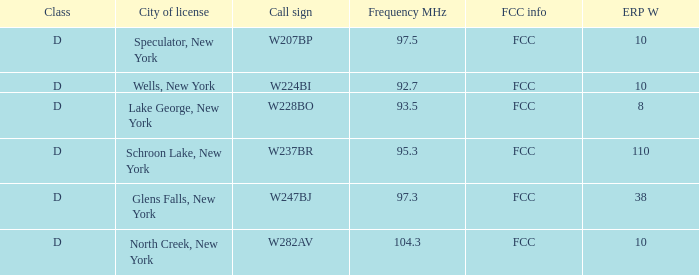Help me parse the entirety of this table. {'header': ['Class', 'City of license', 'Call sign', 'Frequency MHz', 'FCC info', 'ERP W'], 'rows': [['D', 'Speculator, New York', 'W207BP', '97.5', 'FCC', '10'], ['D', 'Wells, New York', 'W224BI', '92.7', 'FCC', '10'], ['D', 'Lake George, New York', 'W228BO', '93.5', 'FCC', '8'], ['D', 'Schroon Lake, New York', 'W237BR', '95.3', 'FCC', '110'], ['D', 'Glens Falls, New York', 'W247BJ', '97.3', 'FCC', '38'], ['D', 'North Creek, New York', 'W282AV', '104.3', 'FCC', '10']]} Name the ERP W for glens falls, new york 38.0. 